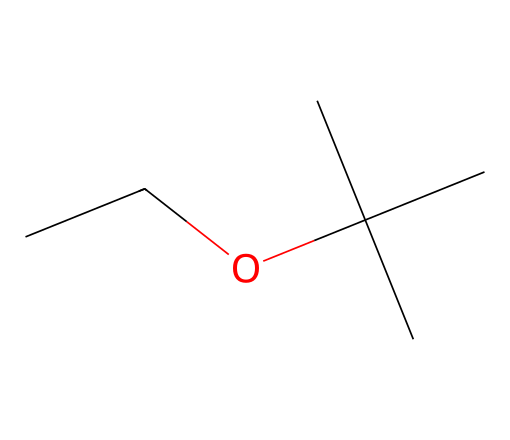What is the molecular formula of ethyl tert-butyl ether? To determine the molecular formula, we count the number of each type of atom in the SMILES representation. The structure CC(O)C(C)(C)C indicates that there are 8 carbon (C) atoms, 18 hydrogen (H) atoms, and 1 oxygen (O) atom, giving us the molecular formula C8H18O.
Answer: C8H18O How many carbon atoms are present in the structure? By analyzing the SMILES structure, we can identify that there are 8 carbon atoms represented. Each carbon (C) symbol in the structure indicates an individual carbon atom.
Answer: 8 What type of functional group is present in ethyl tert-butyl ether? The presence of an oxygen atom (O) connected to two alkyl groups (ethyl and tert-butyl) indicates that this compound contains an ether functional group, characterized by the general structure R-O-R'.
Answer: ether Can this structure be classified as a branched alkane? Yes, the structure shows branched groups, specifically tert-butyl, which is a branched alkyl group attached to the ethyl group. This characteristic of having branches in its carbon backbone qualifies it as a branched alkane.
Answer: yes What is the significance of this compound as an oxygenate additive in gasoline? Ethyl tert-butyl ether has a higher oxygen content compared to conventional hydrocarbons. This oxygenate characteristic helps improve combustion efficiency and reduces emissions in gasoline, enhancing fuel performance.
Answer: improves combustion Is ethyl tert-butyl ether soluble in water? Typically, ethers are less soluble in water because of their hydrophobic hydrocarbon components. Ethyl tert-butyl ether, despite containing an oxygen atom, has a larger hydrophobic part, leading to relatively low water solubility compared to alcohols.
Answer: no 